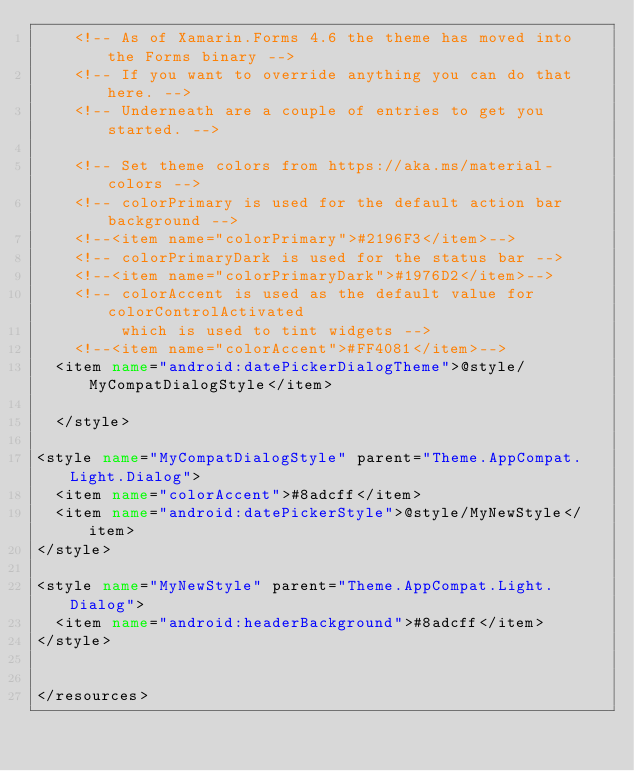<code> <loc_0><loc_0><loc_500><loc_500><_XML_>    <!-- As of Xamarin.Forms 4.6 the theme has moved into the Forms binary -->
    <!-- If you want to override anything you can do that here. -->
    <!-- Underneath are a couple of entries to get you started. -->

    <!-- Set theme colors from https://aka.ms/material-colors -->
    <!-- colorPrimary is used for the default action bar background -->
    <!--<item name="colorPrimary">#2196F3</item>-->
    <!-- colorPrimaryDark is used for the status bar -->
    <!--<item name="colorPrimaryDark">#1976D2</item>-->
    <!-- colorAccent is used as the default value for colorControlActivated
         which is used to tint widgets -->
    <!--<item name="colorAccent">#FF4081</item>-->
  <item name="android:datePickerDialogTheme">@style/MyCompatDialogStyle</item>
  
  </style>
  
<style name="MyCompatDialogStyle" parent="Theme.AppCompat.Light.Dialog">
  <item name="colorAccent">#8adcff</item>
  <item name="android:datePickerStyle">@style/MyNewStyle</item>
</style>
  
<style name="MyNewStyle" parent="Theme.AppCompat.Light.Dialog">
  <item name="android:headerBackground">#8adcff</item>
</style>


</resources></code> 